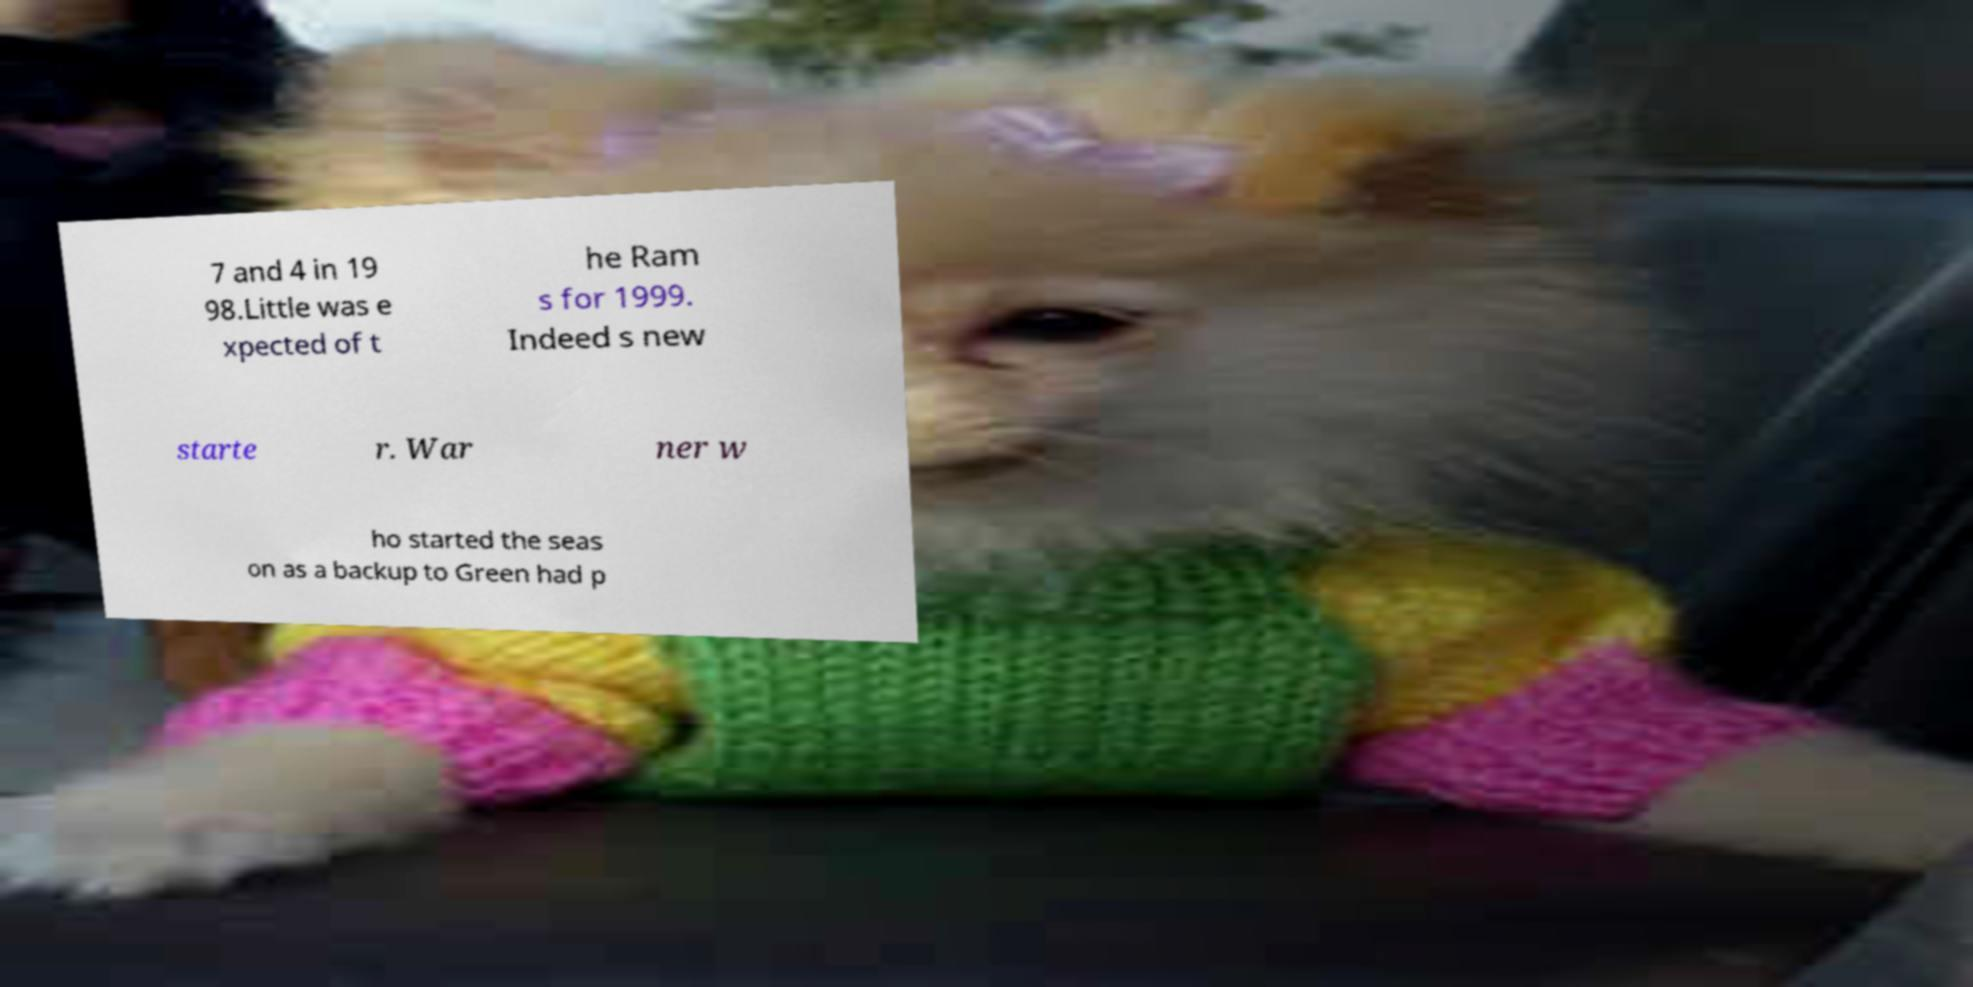Could you extract and type out the text from this image? 7 and 4 in 19 98.Little was e xpected of t he Ram s for 1999. Indeed s new starte r. War ner w ho started the seas on as a backup to Green had p 